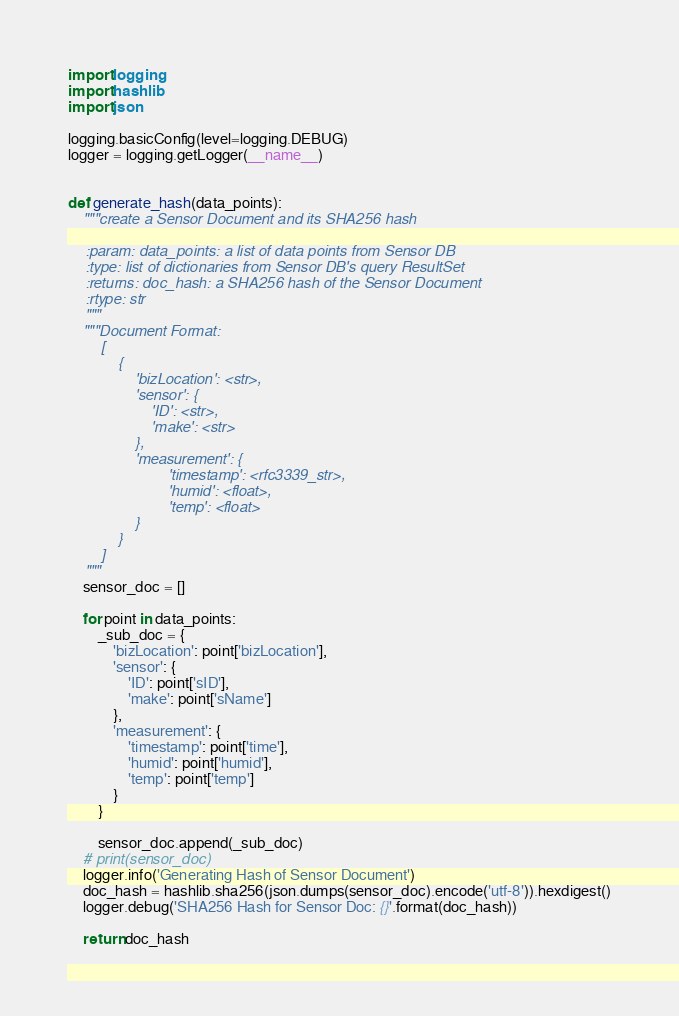Convert code to text. <code><loc_0><loc_0><loc_500><loc_500><_Python_>import logging
import hashlib
import json

logging.basicConfig(level=logging.DEBUG)
logger = logging.getLogger(__name__)


def generate_hash(data_points):
    """create a Sensor Document and its SHA256 hash

    :param: data_points: a list of data points from Sensor DB
    :type: list of dictionaries from Sensor DB's query ResultSet
    :returns: doc_hash: a SHA256 hash of the Sensor Document
    :rtype: str
    """
    """Document Format:
        [
            {
                'bizLocation': <str>,
                'sensor': {
                    'ID': <str>,
                    'make': <str>
                },
                'measurement': {
                        'timestamp': <rfc3339_str>,
                        'humid': <float>,
                        'temp': <float>
                }
            }
        ]
    """
    sensor_doc = []

    for point in data_points:
        _sub_doc = {
            'bizLocation': point['bizLocation'],
            'sensor': {
                'ID': point['sID'],
                'make': point['sName']
            },
            'measurement': {
                'timestamp': point['time'],
                'humid': point['humid'],
                'temp': point['temp']
            }
        }

        sensor_doc.append(_sub_doc)
    # print(sensor_doc)
    logger.info('Generating Hash of Sensor Document')
    doc_hash = hashlib.sha256(json.dumps(sensor_doc).encode('utf-8')).hexdigest()
    logger.debug('SHA256 Hash for Sensor Doc: {}'.format(doc_hash))

    return doc_hash
</code> 